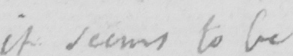Transcribe the text shown in this historical manuscript line. it seems to be 